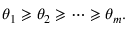<formula> <loc_0><loc_0><loc_500><loc_500>\theta _ { 1 } \geqslant \theta _ { 2 } \geqslant \dots \geqslant \theta _ { m } .</formula> 